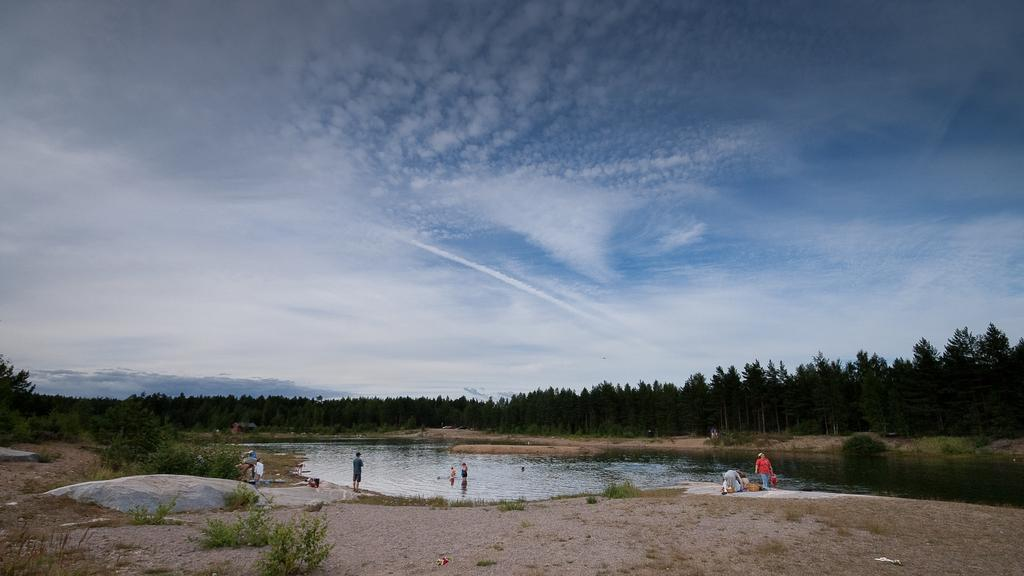Where was the image taken? The image was clicked outside the city. What is the main subject of the image? There is a group of persons in the center of the image. What natural feature can be seen in the image? There is a water body in the image. What type of vegetation is present in the image? There are plants and trees in the image. What can be seen in the background of the image? The sky and trees are visible in the background of the image. What type of bubble is floating near the group of persons in the image? There is no bubble present in the image. Who is the writer in the image? There is no writer present in the image; it features a group of persons in the center. 